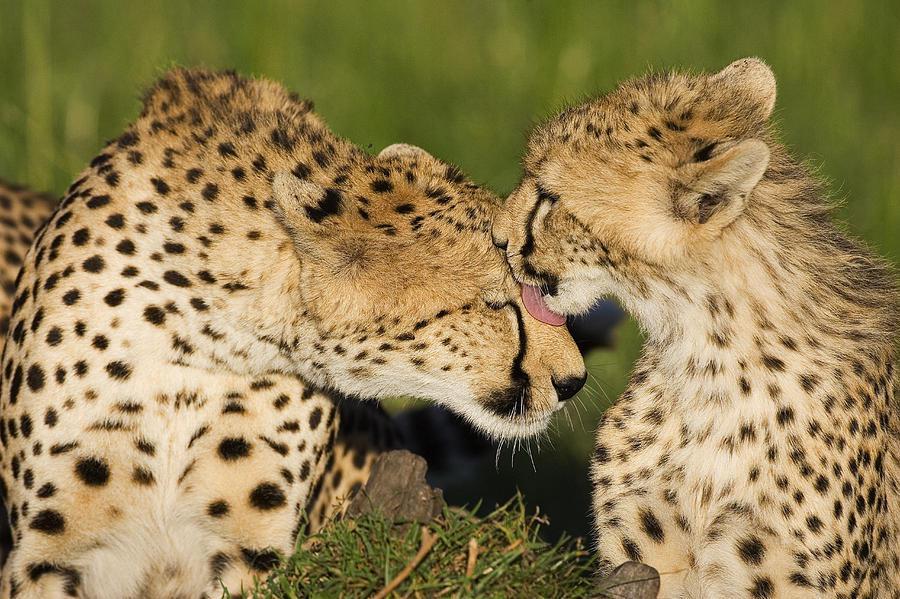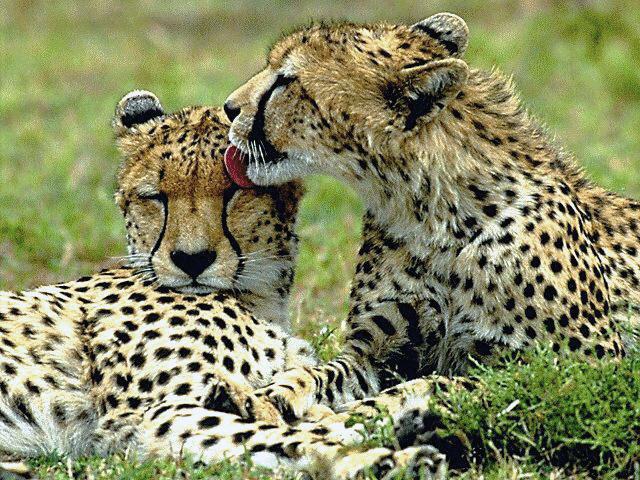The first image is the image on the left, the second image is the image on the right. Considering the images on both sides, is "In one image there is an adult cheetah standing over two younger cheetahs." valid? Answer yes or no. No. 